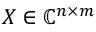<formula> <loc_0><loc_0><loc_500><loc_500>X \in \mathbb { C } ^ { n \times m }</formula> 